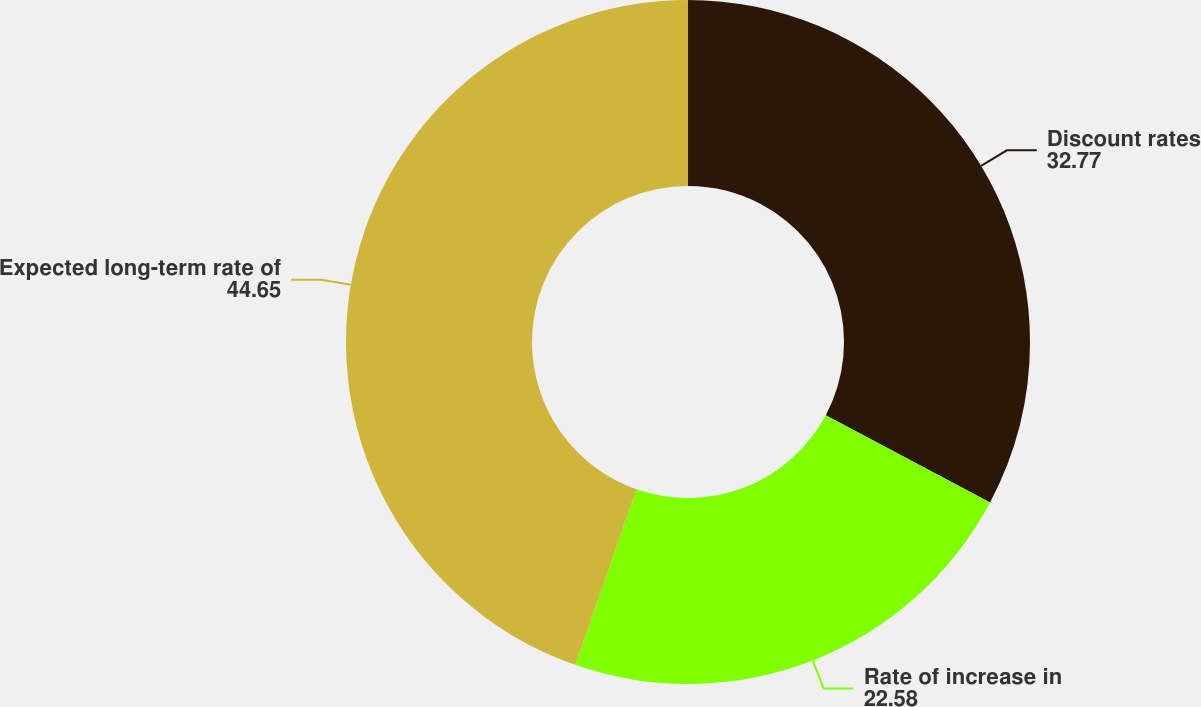Convert chart to OTSL. <chart><loc_0><loc_0><loc_500><loc_500><pie_chart><fcel>Discount rates<fcel>Rate of increase in<fcel>Expected long-term rate of<nl><fcel>32.77%<fcel>22.58%<fcel>44.65%<nl></chart> 